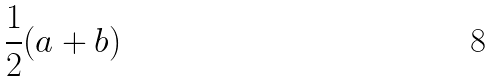<formula> <loc_0><loc_0><loc_500><loc_500>\frac { 1 } { 2 } ( a + b )</formula> 